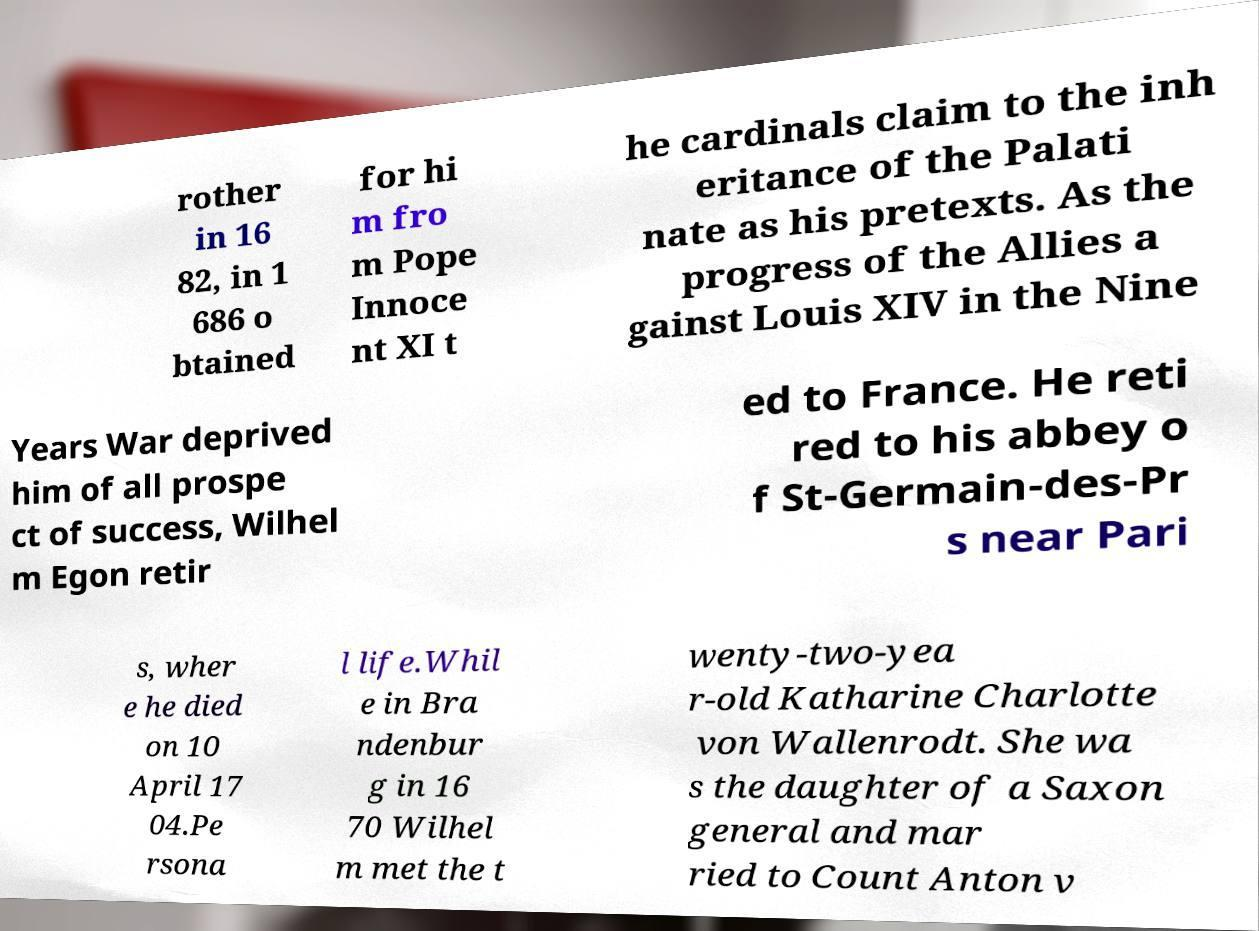Please read and relay the text visible in this image. What does it say? rother in 16 82, in 1 686 o btained for hi m fro m Pope Innoce nt XI t he cardinals claim to the inh eritance of the Palati nate as his pretexts. As the progress of the Allies a gainst Louis XIV in the Nine Years War deprived him of all prospe ct of success, Wilhel m Egon retir ed to France. He reti red to his abbey o f St-Germain-des-Pr s near Pari s, wher e he died on 10 April 17 04.Pe rsona l life.Whil e in Bra ndenbur g in 16 70 Wilhel m met the t wenty-two-yea r-old Katharine Charlotte von Wallenrodt. She wa s the daughter of a Saxon general and mar ried to Count Anton v 